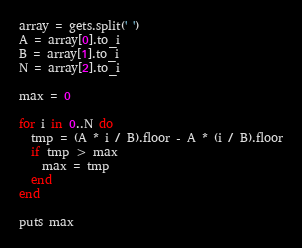<code> <loc_0><loc_0><loc_500><loc_500><_Ruby_>array = gets.split(' ')
A = array[0].to_i
B = array[1].to_i
N = array[2].to_i

max = 0

for i in 0..N do
  tmp = (A * i / B).floor - A * (i / B).floor
  if tmp > max
    max = tmp
  end
end

puts max</code> 